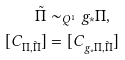<formula> <loc_0><loc_0><loc_500><loc_500>\tilde { \Pi } & \sim _ { Q ^ { 1 } } g _ { \ast } \Pi , \\ [ C _ { \Pi , \tilde { \Pi } } ] & = [ C _ { g _ { \ast } \Pi , \tilde { \Pi } } ]</formula> 